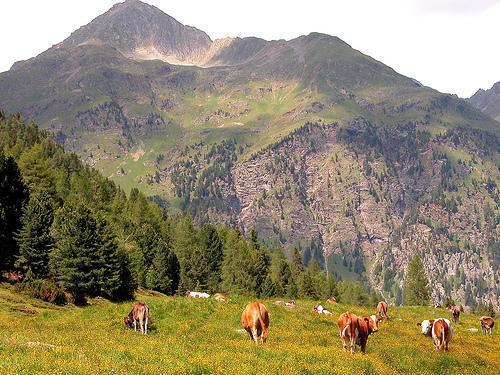How many cows  are here?
Give a very brief answer. 12. 